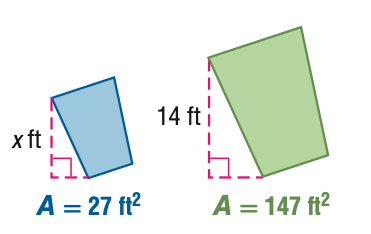Answer the mathemtical geometry problem and directly provide the correct option letter.
Question: For the pair of similar figures, use the given areas to find x.
Choices: A: 2.6 B: 6.0 C: 32.7 D: 76.2 B 